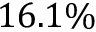<formula> <loc_0><loc_0><loc_500><loc_500>1 6 . 1 \%</formula> 